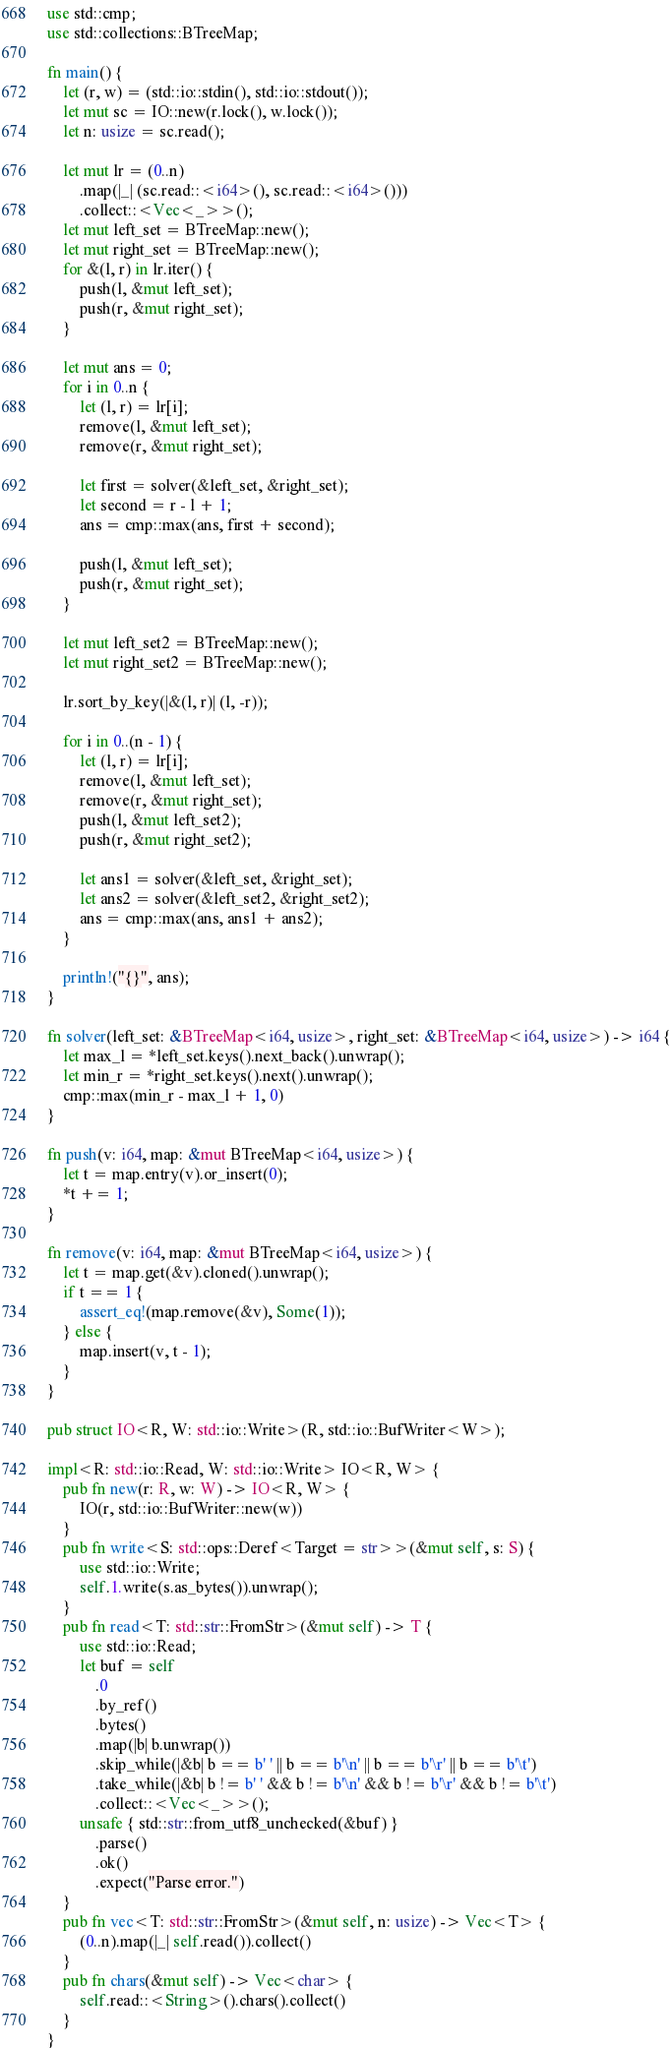Convert code to text. <code><loc_0><loc_0><loc_500><loc_500><_Rust_>use std::cmp;
use std::collections::BTreeMap;

fn main() {
    let (r, w) = (std::io::stdin(), std::io::stdout());
    let mut sc = IO::new(r.lock(), w.lock());
    let n: usize = sc.read();

    let mut lr = (0..n)
        .map(|_| (sc.read::<i64>(), sc.read::<i64>()))
        .collect::<Vec<_>>();
    let mut left_set = BTreeMap::new();
    let mut right_set = BTreeMap::new();
    for &(l, r) in lr.iter() {
        push(l, &mut left_set);
        push(r, &mut right_set);
    }

    let mut ans = 0;
    for i in 0..n {
        let (l, r) = lr[i];
        remove(l, &mut left_set);
        remove(r, &mut right_set);

        let first = solver(&left_set, &right_set);
        let second = r - l + 1;
        ans = cmp::max(ans, first + second);

        push(l, &mut left_set);
        push(r, &mut right_set);
    }

    let mut left_set2 = BTreeMap::new();
    let mut right_set2 = BTreeMap::new();

    lr.sort_by_key(|&(l, r)| (l, -r));

    for i in 0..(n - 1) {
        let (l, r) = lr[i];
        remove(l, &mut left_set);
        remove(r, &mut right_set);
        push(l, &mut left_set2);
        push(r, &mut right_set2);

        let ans1 = solver(&left_set, &right_set);
        let ans2 = solver(&left_set2, &right_set2);
        ans = cmp::max(ans, ans1 + ans2);
    }

    println!("{}", ans);
}

fn solver(left_set: &BTreeMap<i64, usize>, right_set: &BTreeMap<i64, usize>) -> i64 {
    let max_l = *left_set.keys().next_back().unwrap();
    let min_r = *right_set.keys().next().unwrap();
    cmp::max(min_r - max_l + 1, 0)
}

fn push(v: i64, map: &mut BTreeMap<i64, usize>) {
    let t = map.entry(v).or_insert(0);
    *t += 1;
}

fn remove(v: i64, map: &mut BTreeMap<i64, usize>) {
    let t = map.get(&v).cloned().unwrap();
    if t == 1 {
        assert_eq!(map.remove(&v), Some(1));
    } else {
        map.insert(v, t - 1);
    }
}

pub struct IO<R, W: std::io::Write>(R, std::io::BufWriter<W>);

impl<R: std::io::Read, W: std::io::Write> IO<R, W> {
    pub fn new(r: R, w: W) -> IO<R, W> {
        IO(r, std::io::BufWriter::new(w))
    }
    pub fn write<S: std::ops::Deref<Target = str>>(&mut self, s: S) {
        use std::io::Write;
        self.1.write(s.as_bytes()).unwrap();
    }
    pub fn read<T: std::str::FromStr>(&mut self) -> T {
        use std::io::Read;
        let buf = self
            .0
            .by_ref()
            .bytes()
            .map(|b| b.unwrap())
            .skip_while(|&b| b == b' ' || b == b'\n' || b == b'\r' || b == b'\t')
            .take_while(|&b| b != b' ' && b != b'\n' && b != b'\r' && b != b'\t')
            .collect::<Vec<_>>();
        unsafe { std::str::from_utf8_unchecked(&buf) }
            .parse()
            .ok()
            .expect("Parse error.")
    }
    pub fn vec<T: std::str::FromStr>(&mut self, n: usize) -> Vec<T> {
        (0..n).map(|_| self.read()).collect()
    }
    pub fn chars(&mut self) -> Vec<char> {
        self.read::<String>().chars().collect()
    }
}
</code> 